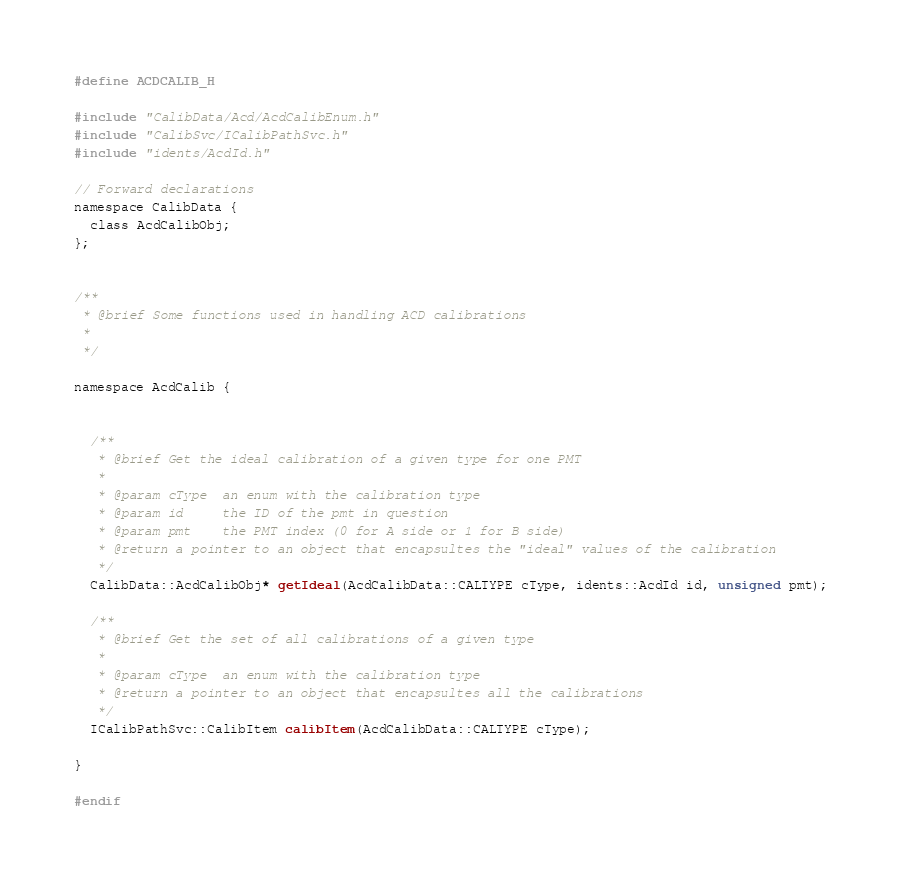Convert code to text. <code><loc_0><loc_0><loc_500><loc_500><_C_>#define ACDCALIB_H

#include "CalibData/Acd/AcdCalibEnum.h"
#include "CalibSvc/ICalibPathSvc.h"
#include "idents/AcdId.h" 

// Forward declarations
namespace CalibData {
  class AcdCalibObj;
};


/**
 * @brief Some functions used in handling ACD calibrations
 *
 */

namespace AcdCalib {
  

  /**
   * @brief Get the ideal calibration of a given type for one PMT
   *
   * @param cType  an enum with the calibration type
   * @param id     the ID of the pmt in question
   * @param pmt    the PMT index (0 for A side or 1 for B side) 
   * @return a pointer to an object that encapsultes the "ideal" values of the calibration
   */
  CalibData::AcdCalibObj* getIdeal(AcdCalibData::CALTYPE cType, idents::AcdId id, unsigned pmt);

  /**
   * @brief Get the set of all calibrations of a given type
   *
   * @param cType  an enum with the calibration type
   * @return a pointer to an object that encapsultes all the calibrations
   */  
  ICalibPathSvc::CalibItem calibItem(AcdCalibData::CALTYPE cType); 

}

#endif
</code> 